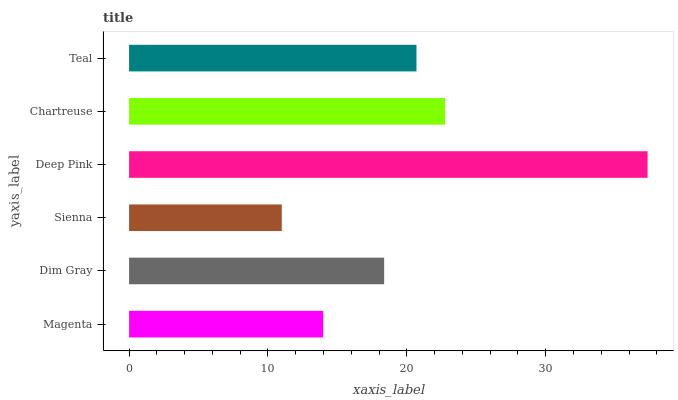Is Sienna the minimum?
Answer yes or no. Yes. Is Deep Pink the maximum?
Answer yes or no. Yes. Is Dim Gray the minimum?
Answer yes or no. No. Is Dim Gray the maximum?
Answer yes or no. No. Is Dim Gray greater than Magenta?
Answer yes or no. Yes. Is Magenta less than Dim Gray?
Answer yes or no. Yes. Is Magenta greater than Dim Gray?
Answer yes or no. No. Is Dim Gray less than Magenta?
Answer yes or no. No. Is Teal the high median?
Answer yes or no. Yes. Is Dim Gray the low median?
Answer yes or no. Yes. Is Chartreuse the high median?
Answer yes or no. No. Is Chartreuse the low median?
Answer yes or no. No. 